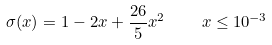Convert formula to latex. <formula><loc_0><loc_0><loc_500><loc_500>\sigma ( x ) = 1 - 2 x + { \frac { 2 6 } { 5 } } x ^ { 2 } \quad x \leq 1 0 ^ { - 3 }</formula> 